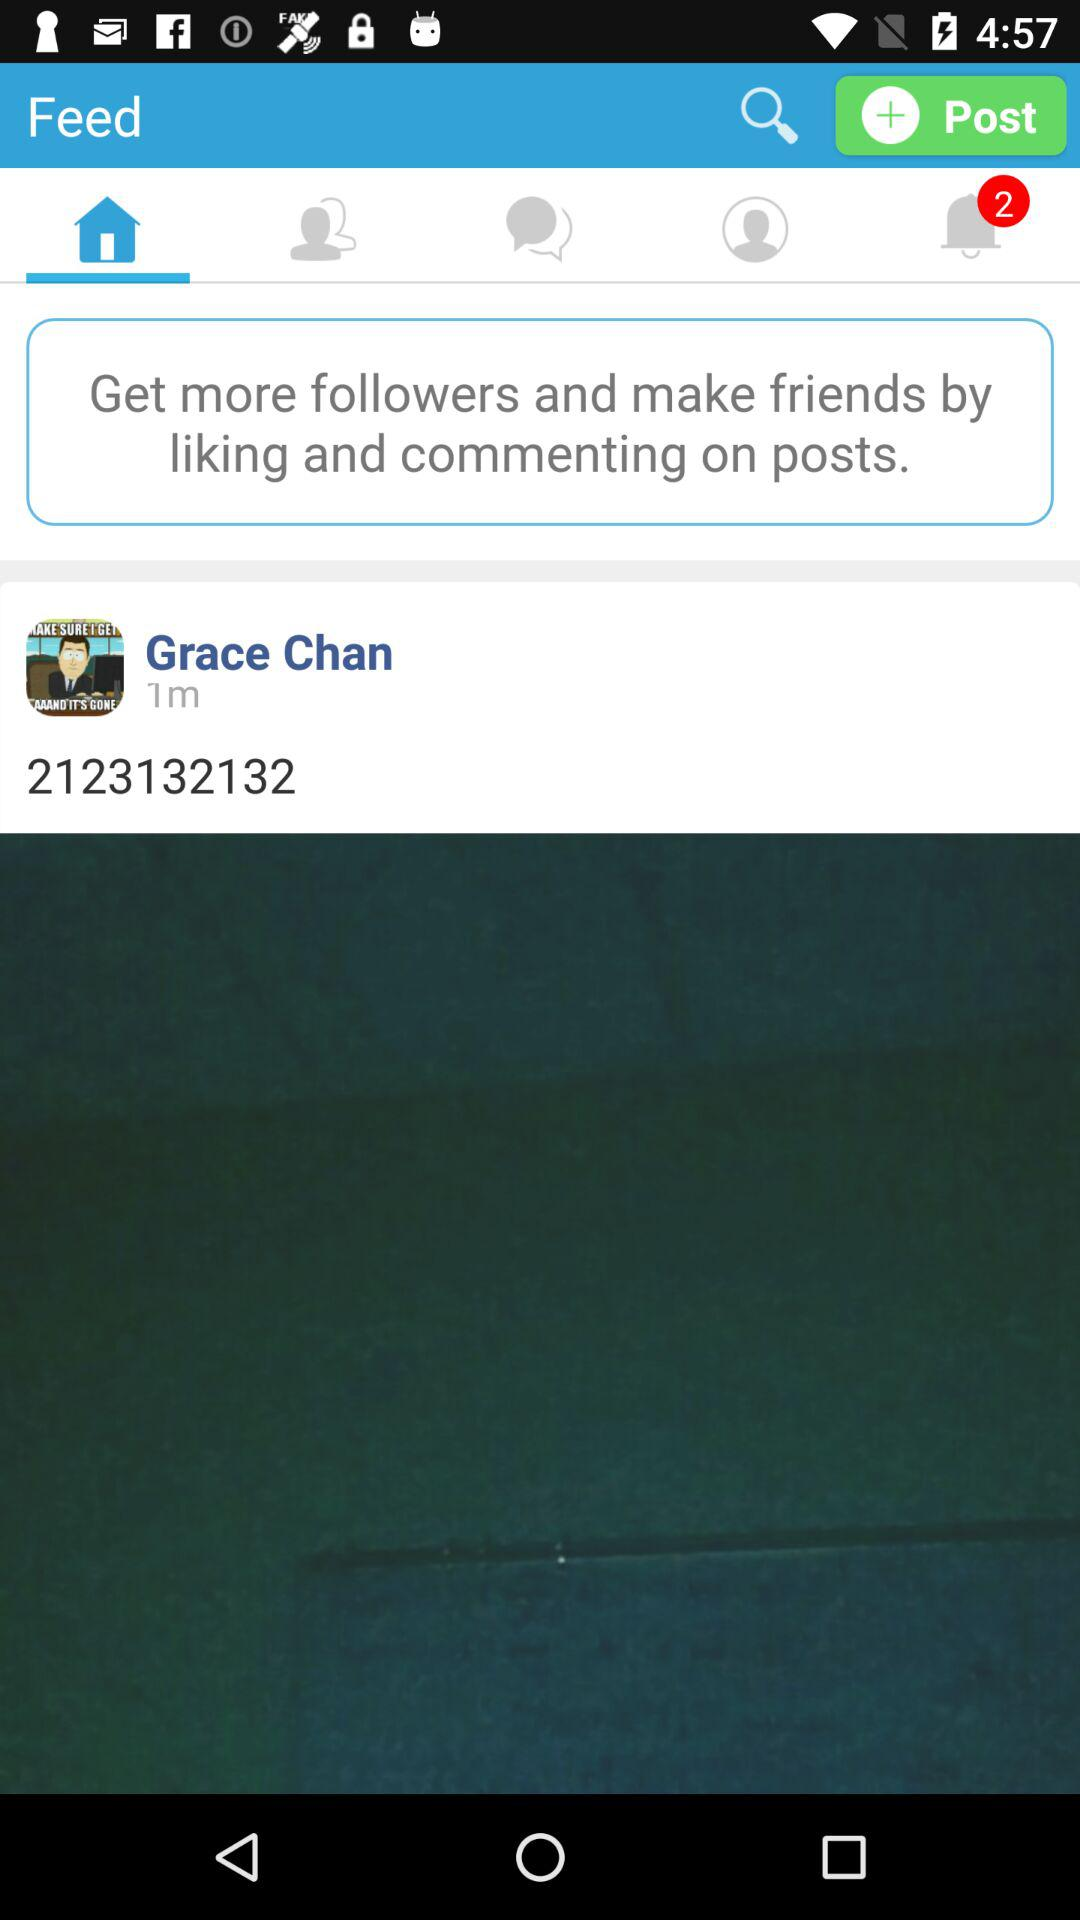When was the post posted? The post was posted 1 minute ago. 